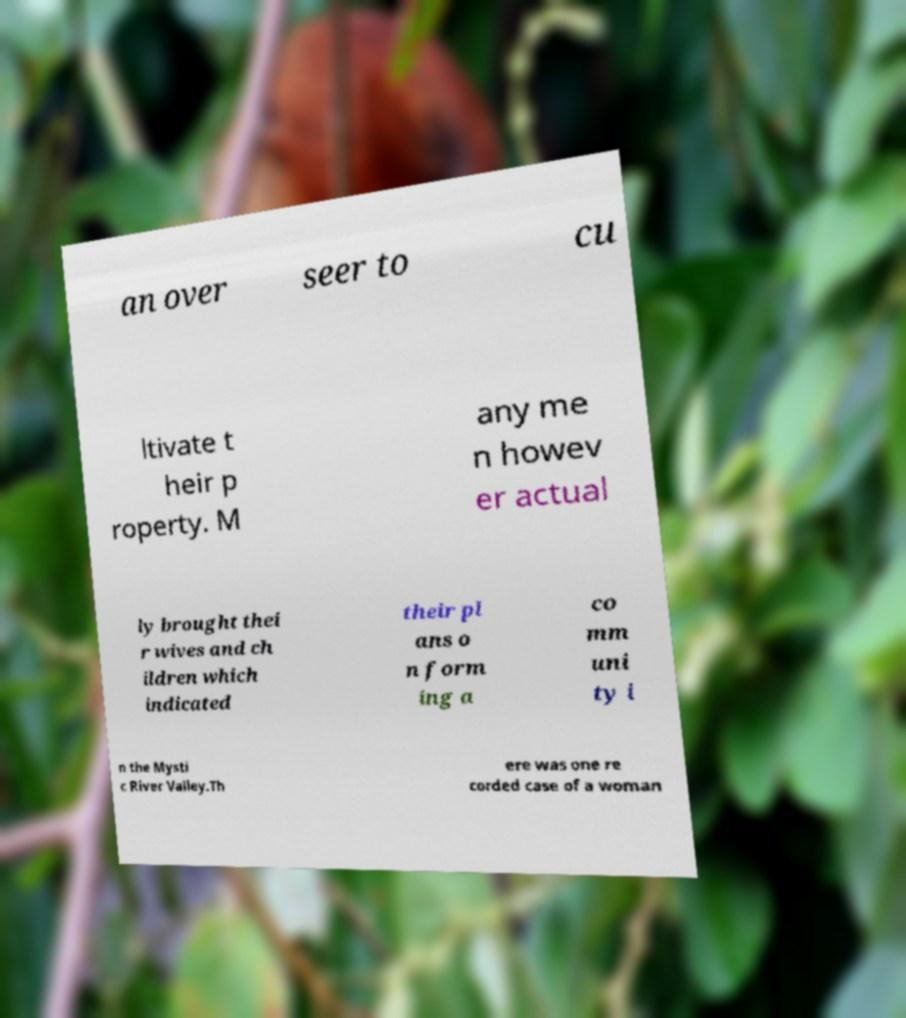Please read and relay the text visible in this image. What does it say? an over seer to cu ltivate t heir p roperty. M any me n howev er actual ly brought thei r wives and ch ildren which indicated their pl ans o n form ing a co mm uni ty i n the Mysti c River Valley.Th ere was one re corded case of a woman 